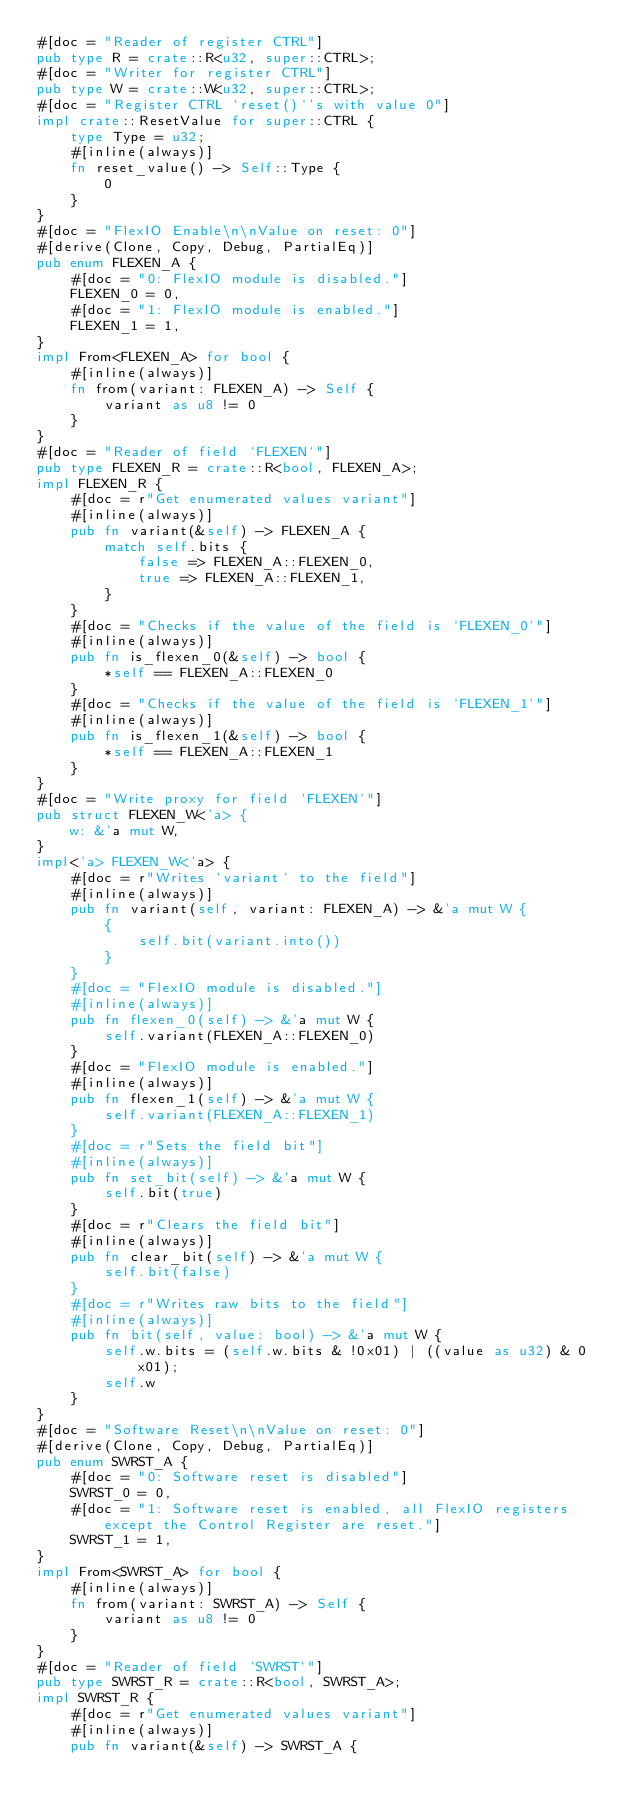Convert code to text. <code><loc_0><loc_0><loc_500><loc_500><_Rust_>#[doc = "Reader of register CTRL"]
pub type R = crate::R<u32, super::CTRL>;
#[doc = "Writer for register CTRL"]
pub type W = crate::W<u32, super::CTRL>;
#[doc = "Register CTRL `reset()`'s with value 0"]
impl crate::ResetValue for super::CTRL {
    type Type = u32;
    #[inline(always)]
    fn reset_value() -> Self::Type {
        0
    }
}
#[doc = "FlexIO Enable\n\nValue on reset: 0"]
#[derive(Clone, Copy, Debug, PartialEq)]
pub enum FLEXEN_A {
    #[doc = "0: FlexIO module is disabled."]
    FLEXEN_0 = 0,
    #[doc = "1: FlexIO module is enabled."]
    FLEXEN_1 = 1,
}
impl From<FLEXEN_A> for bool {
    #[inline(always)]
    fn from(variant: FLEXEN_A) -> Self {
        variant as u8 != 0
    }
}
#[doc = "Reader of field `FLEXEN`"]
pub type FLEXEN_R = crate::R<bool, FLEXEN_A>;
impl FLEXEN_R {
    #[doc = r"Get enumerated values variant"]
    #[inline(always)]
    pub fn variant(&self) -> FLEXEN_A {
        match self.bits {
            false => FLEXEN_A::FLEXEN_0,
            true => FLEXEN_A::FLEXEN_1,
        }
    }
    #[doc = "Checks if the value of the field is `FLEXEN_0`"]
    #[inline(always)]
    pub fn is_flexen_0(&self) -> bool {
        *self == FLEXEN_A::FLEXEN_0
    }
    #[doc = "Checks if the value of the field is `FLEXEN_1`"]
    #[inline(always)]
    pub fn is_flexen_1(&self) -> bool {
        *self == FLEXEN_A::FLEXEN_1
    }
}
#[doc = "Write proxy for field `FLEXEN`"]
pub struct FLEXEN_W<'a> {
    w: &'a mut W,
}
impl<'a> FLEXEN_W<'a> {
    #[doc = r"Writes `variant` to the field"]
    #[inline(always)]
    pub fn variant(self, variant: FLEXEN_A) -> &'a mut W {
        {
            self.bit(variant.into())
        }
    }
    #[doc = "FlexIO module is disabled."]
    #[inline(always)]
    pub fn flexen_0(self) -> &'a mut W {
        self.variant(FLEXEN_A::FLEXEN_0)
    }
    #[doc = "FlexIO module is enabled."]
    #[inline(always)]
    pub fn flexen_1(self) -> &'a mut W {
        self.variant(FLEXEN_A::FLEXEN_1)
    }
    #[doc = r"Sets the field bit"]
    #[inline(always)]
    pub fn set_bit(self) -> &'a mut W {
        self.bit(true)
    }
    #[doc = r"Clears the field bit"]
    #[inline(always)]
    pub fn clear_bit(self) -> &'a mut W {
        self.bit(false)
    }
    #[doc = r"Writes raw bits to the field"]
    #[inline(always)]
    pub fn bit(self, value: bool) -> &'a mut W {
        self.w.bits = (self.w.bits & !0x01) | ((value as u32) & 0x01);
        self.w
    }
}
#[doc = "Software Reset\n\nValue on reset: 0"]
#[derive(Clone, Copy, Debug, PartialEq)]
pub enum SWRST_A {
    #[doc = "0: Software reset is disabled"]
    SWRST_0 = 0,
    #[doc = "1: Software reset is enabled, all FlexIO registers except the Control Register are reset."]
    SWRST_1 = 1,
}
impl From<SWRST_A> for bool {
    #[inline(always)]
    fn from(variant: SWRST_A) -> Self {
        variant as u8 != 0
    }
}
#[doc = "Reader of field `SWRST`"]
pub type SWRST_R = crate::R<bool, SWRST_A>;
impl SWRST_R {
    #[doc = r"Get enumerated values variant"]
    #[inline(always)]
    pub fn variant(&self) -> SWRST_A {</code> 